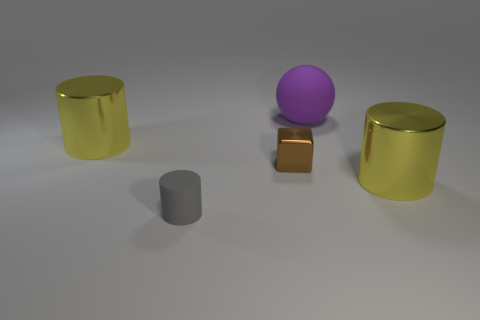Is there a cylinder that has the same size as the brown metallic object?
Make the answer very short. Yes. What is the brown object that is left of the large matte object made of?
Provide a succinct answer. Metal. Are the yellow thing left of the large purple rubber thing and the small brown cube made of the same material?
Offer a very short reply. Yes. There is a matte thing that is the same size as the brown block; what shape is it?
Provide a succinct answer. Cylinder. How many large rubber balls have the same color as the large rubber thing?
Keep it short and to the point. 0. Are there fewer matte objects that are right of the small gray rubber thing than shiny objects to the left of the big purple rubber thing?
Ensure brevity in your answer.  Yes. Are there any yellow cylinders left of the small gray matte cylinder?
Offer a very short reply. Yes. There is a small gray rubber cylinder that is right of the large object on the left side of the small brown cube; is there a purple matte thing that is behind it?
Provide a short and direct response. Yes. Is the shape of the big yellow metal object to the left of the brown thing the same as  the tiny matte thing?
Your answer should be very brief. Yes. There is a small cylinder that is the same material as the large sphere; what color is it?
Your response must be concise. Gray. 